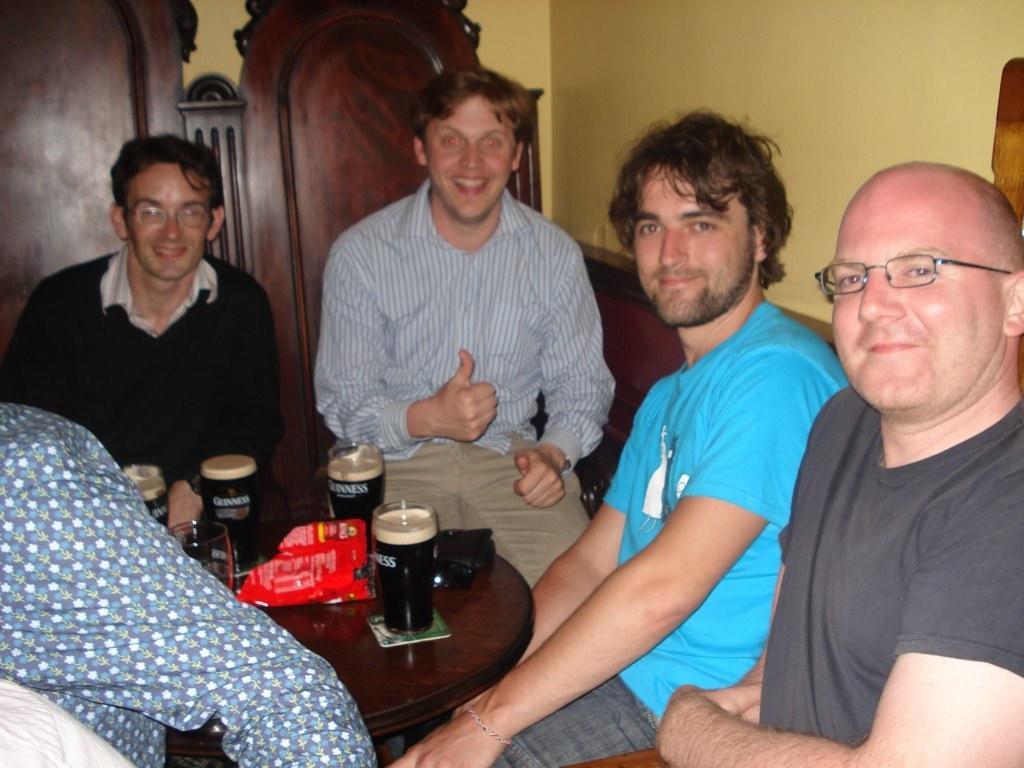Please provide a concise description of this image. In this image we can see men sitting on the chairs and a table is placed in front of them. On the table we can see beverage tumblers and packed foods. In the background there are walls. 